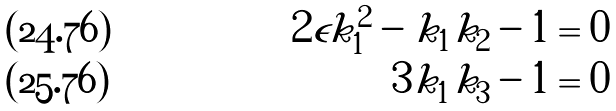Convert formula to latex. <formula><loc_0><loc_0><loc_500><loc_500>2 \epsilon k _ { 1 } ^ { 2 } - k _ { 1 } k _ { 2 } - 1 & = 0 \\ 3 k _ { 1 } k _ { 3 } - 1 & = 0</formula> 